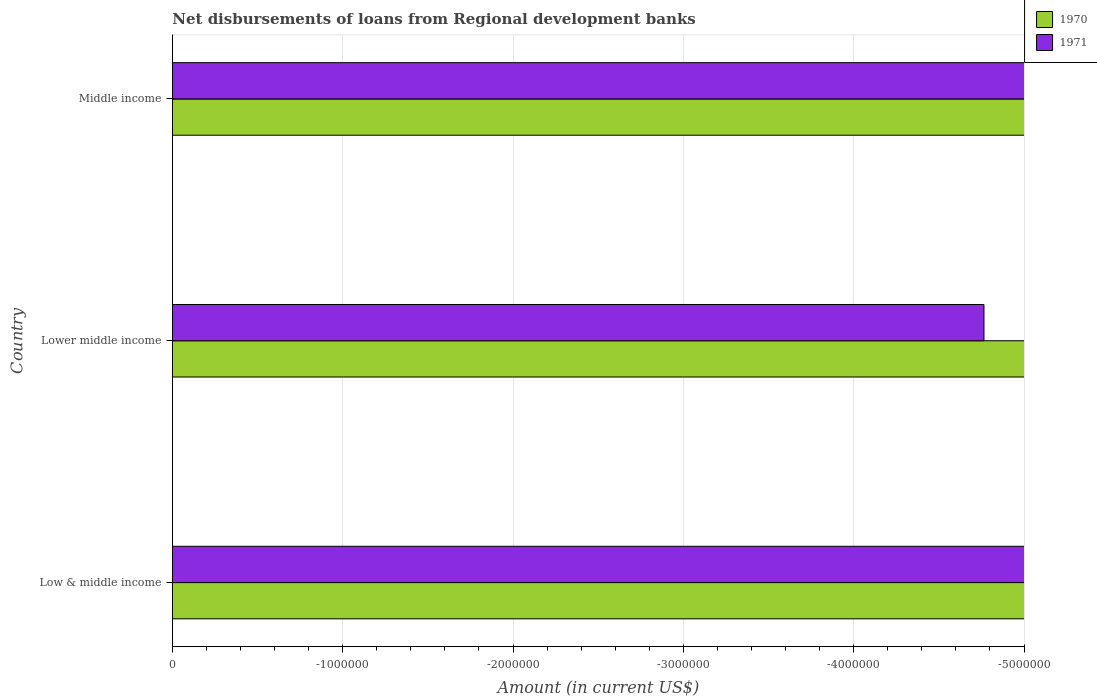What is the label of the 2nd group of bars from the top?
Your answer should be compact. Lower middle income. What is the total amount of disbursements of loans from regional development banks in 1970 in the graph?
Ensure brevity in your answer.  0. How many bars are there?
Give a very brief answer. 0. How many countries are there in the graph?
Your answer should be compact. 3. Does the graph contain grids?
Give a very brief answer. Yes. How many legend labels are there?
Offer a terse response. 2. What is the title of the graph?
Your answer should be very brief. Net disbursements of loans from Regional development banks. Does "1994" appear as one of the legend labels in the graph?
Offer a very short reply. No. What is the label or title of the X-axis?
Keep it short and to the point. Amount (in current US$). What is the label or title of the Y-axis?
Offer a very short reply. Country. What is the Amount (in current US$) in 1970 in Low & middle income?
Ensure brevity in your answer.  0. What is the Amount (in current US$) in 1971 in Lower middle income?
Provide a short and direct response. 0. What is the average Amount (in current US$) of 1970 per country?
Provide a short and direct response. 0. 